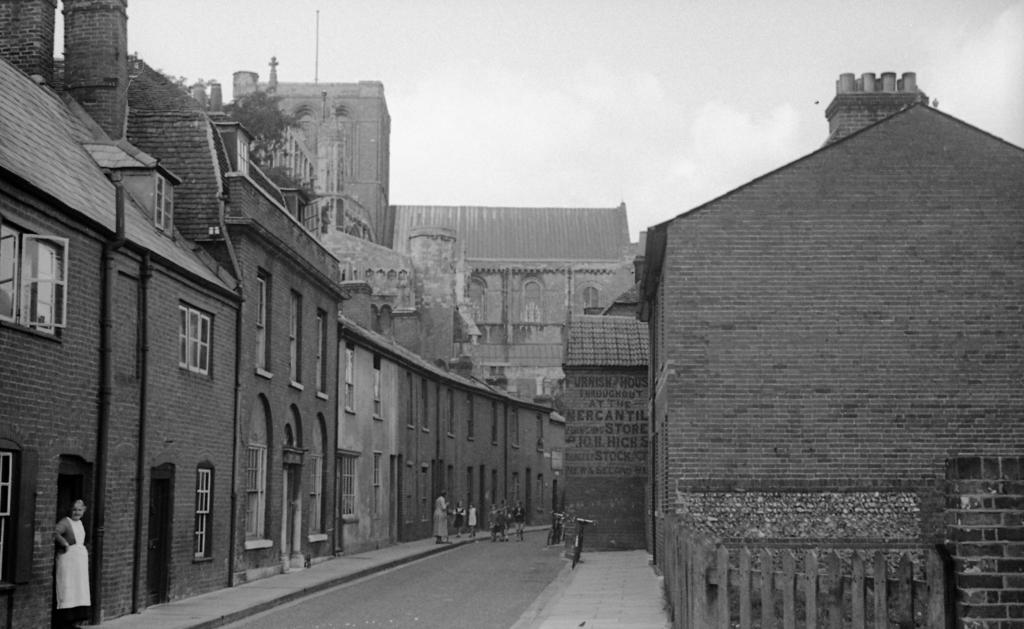What is the color scheme of the image? The image is black and white. What type of structures can be seen in the image? There are buildings in the image. What are the people in the image doing? There are persons standing in the image. What mode of transportation is present in the image? There are bicycles in the image. What type of vegetation is visible in the image? There are plants in the image. What other objects can be seen in the image? There are poles in the image. What part of the natural environment is visible in the image? The sky is visible in the image. How many friends are sitting on the chair in the image? There is no chair present in the image, and therefore no friends can be seen sitting on it. 